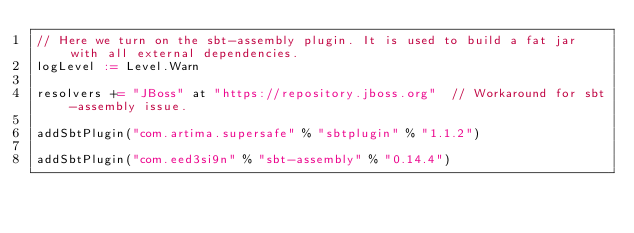Convert code to text. <code><loc_0><loc_0><loc_500><loc_500><_Scala_>// Here we turn on the sbt-assembly plugin. It is used to build a fat jar with all external dependencies.
logLevel := Level.Warn

resolvers += "JBoss" at "https://repository.jboss.org"  // Workaround for sbt-assembly issue.

addSbtPlugin("com.artima.supersafe" % "sbtplugin" % "1.1.2")

addSbtPlugin("com.eed3si9n" % "sbt-assembly" % "0.14.4")</code> 